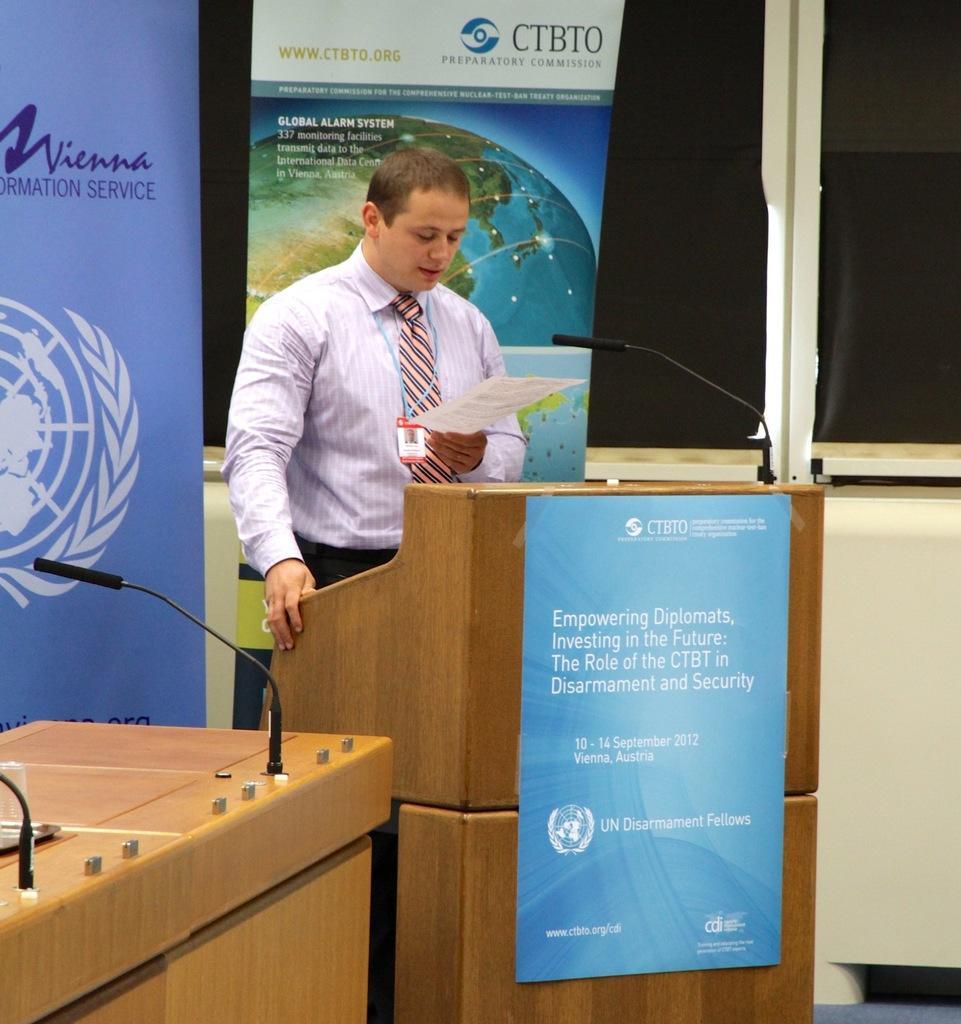Could you give a brief overview of what you see in this image? In this image there is a person standing at the podium holding a paper, on the podium there is a microphone and a poster attached to the podium, there are microphone on the table, few banners. 